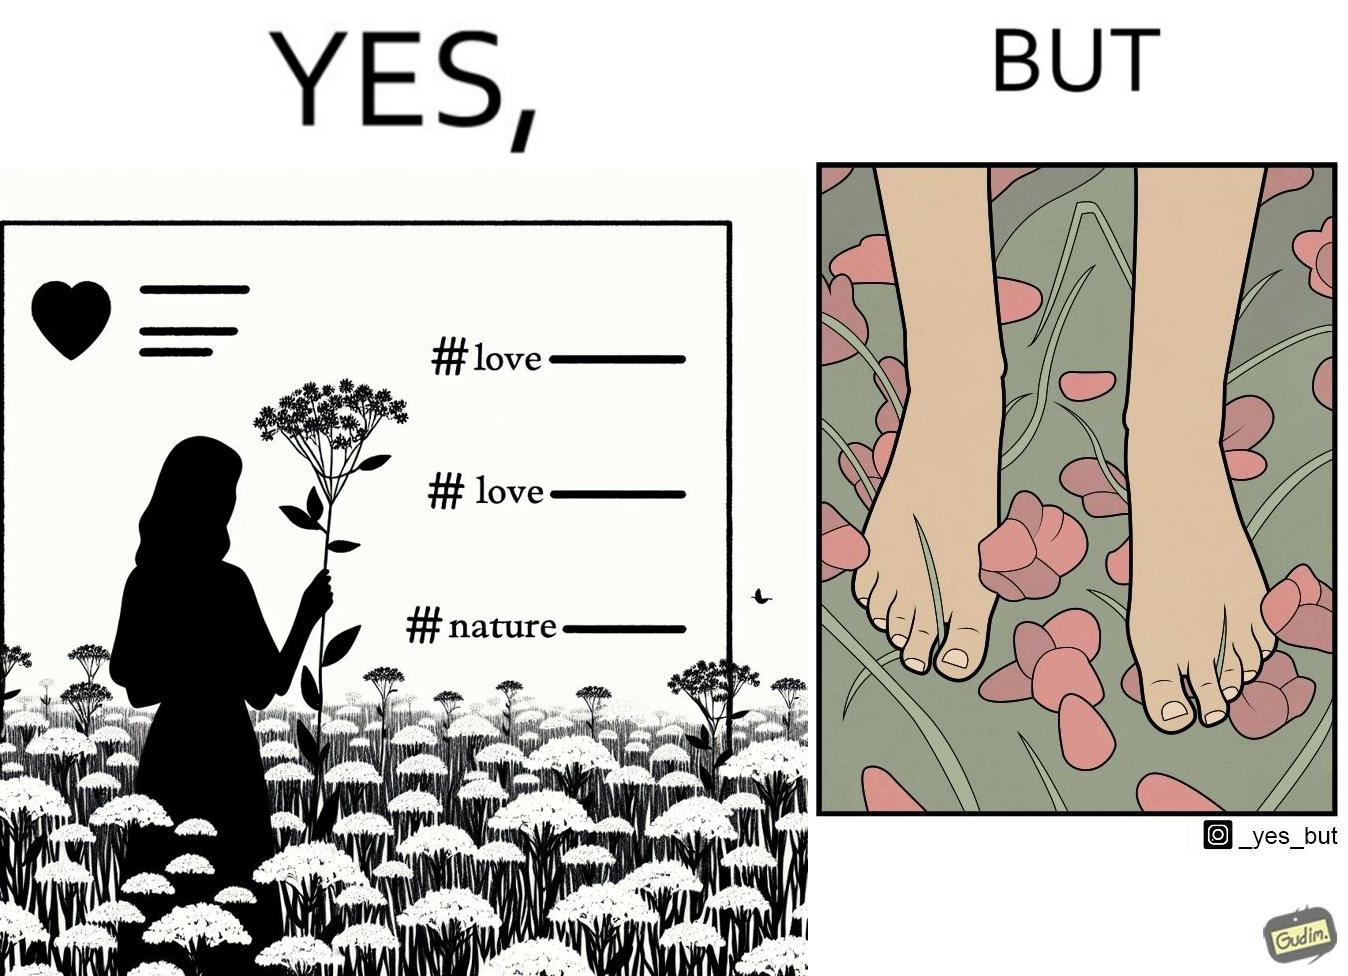Would you classify this image as satirical? Yes, this image is satirical. 